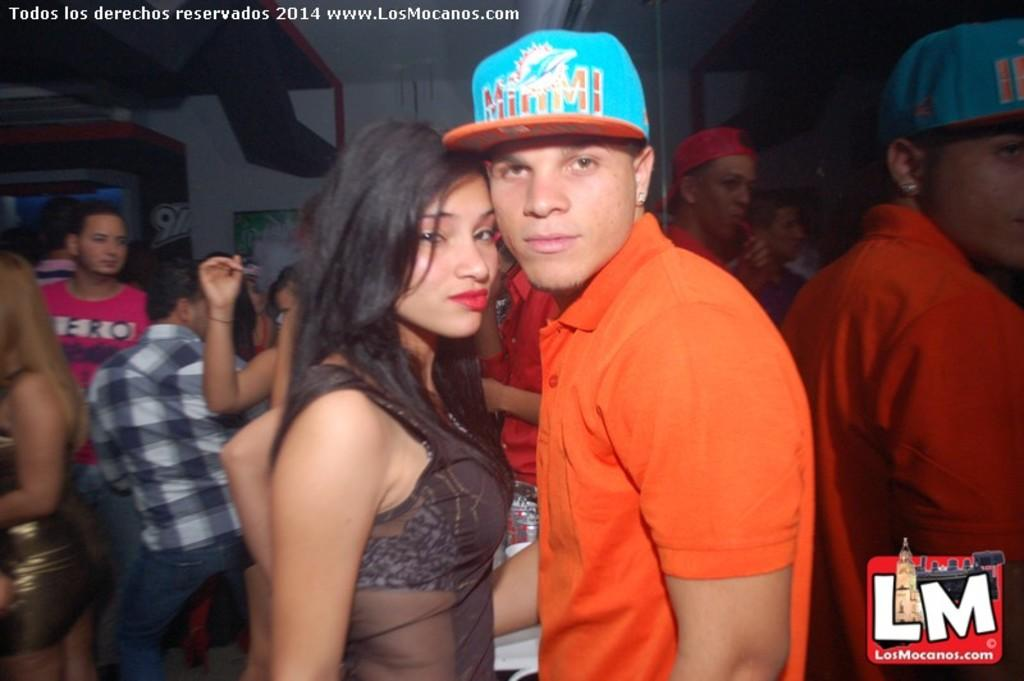<image>
Offer a succinct explanation of the picture presented. A young couple posed at the 2014 Los Mocanos festival. 